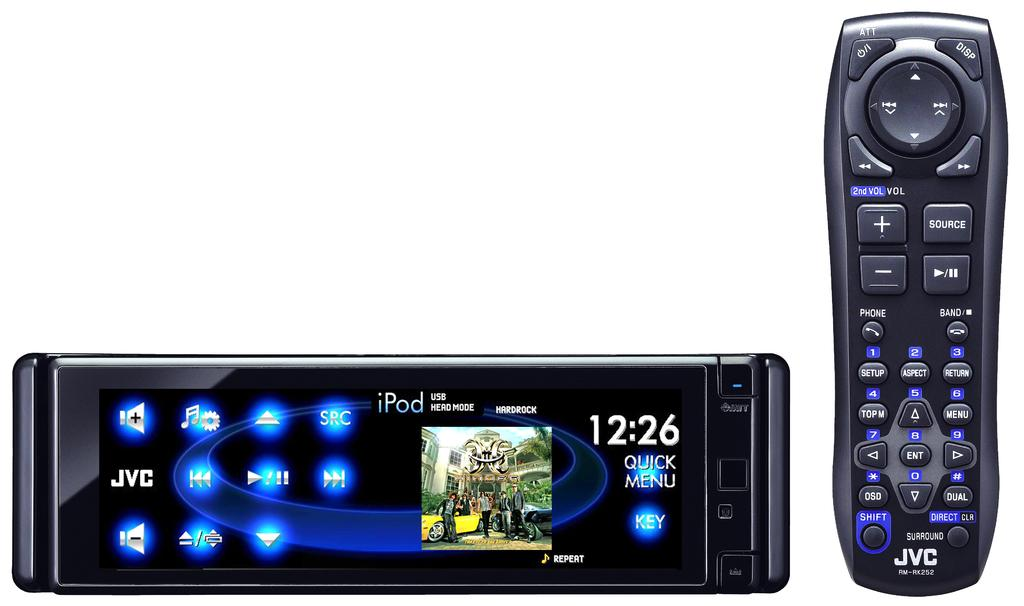<image>
Relay a brief, clear account of the picture shown. An Ipod USB Hard Rock remote showing the time as 12:26 next to a conventional remote. 